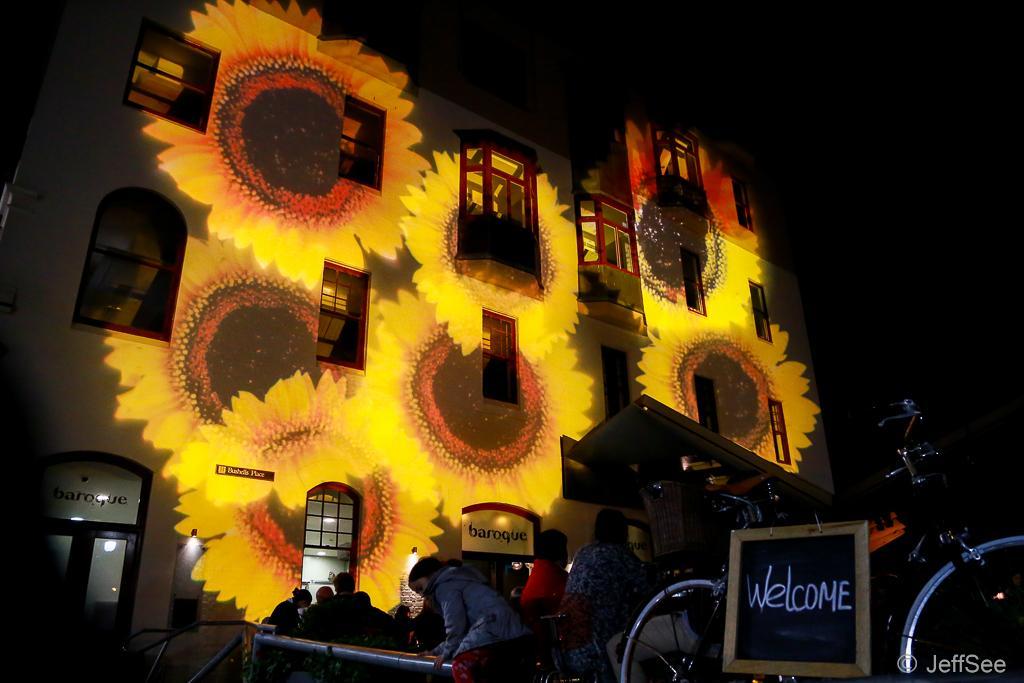In one or two sentences, can you explain what this image depicts? In this picture we can see one building, on it some flower type light focus is focusing. In front of the building few people are standing. 